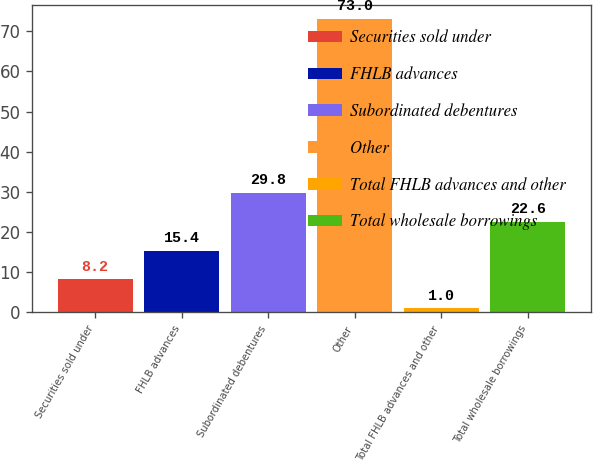<chart> <loc_0><loc_0><loc_500><loc_500><bar_chart><fcel>Securities sold under<fcel>FHLB advances<fcel>Subordinated debentures<fcel>Other<fcel>Total FHLB advances and other<fcel>Total wholesale borrowings<nl><fcel>8.2<fcel>15.4<fcel>29.8<fcel>73<fcel>1<fcel>22.6<nl></chart> 